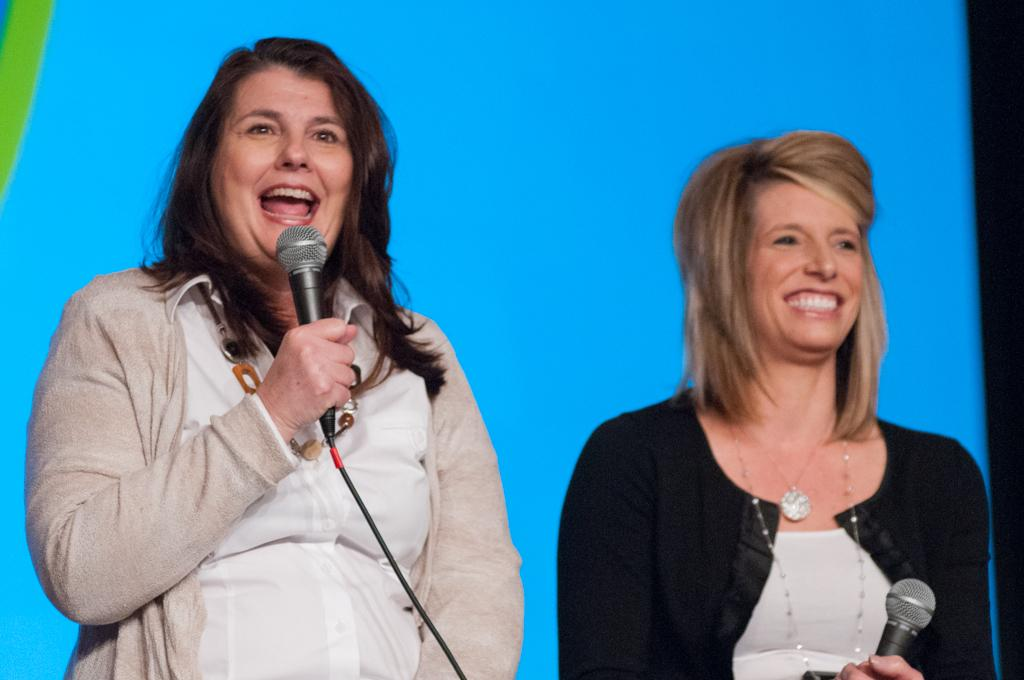How many women are present in the image? There are two women in the image. What are the women doing in the image? Both women are standing and smiling. What objects are the women holding in the image? Each woman is holding a microphone. What can be seen in the background of the image? There is a blue-colored screen in the background of the image. What type of laborer can be seen working in the image? There is no laborer present in the image; it features two women holding microphones. How much money is visible in the image? There is no money visible in the image. 